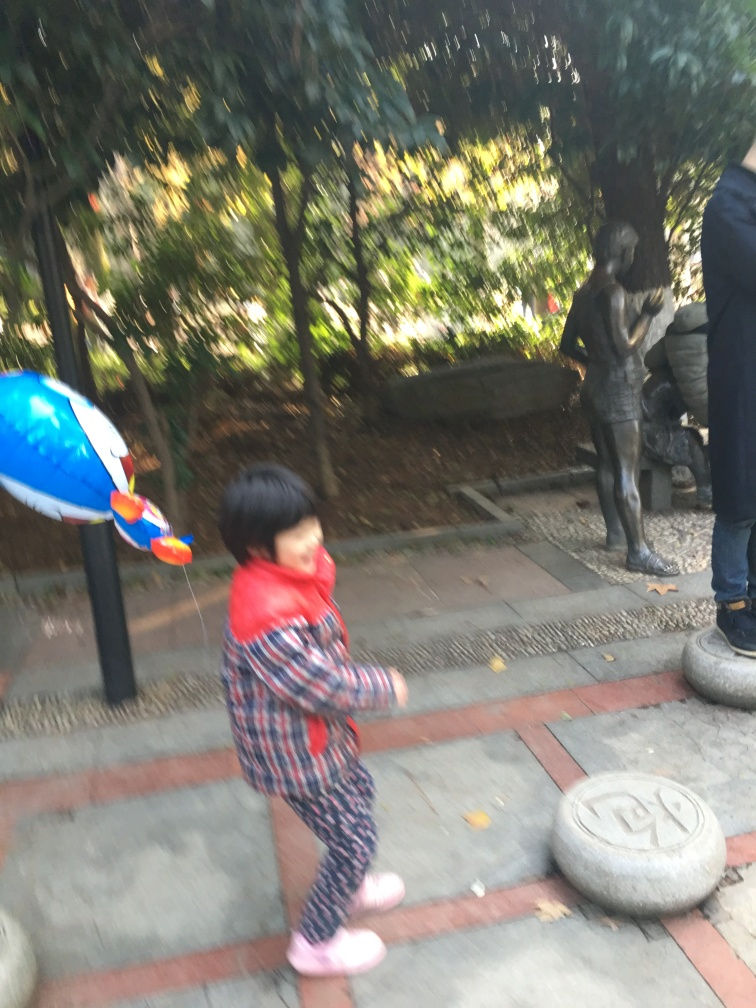Can you describe the setting and the subjects in the photograph? The photograph depicts an outdoor setting with abundant greenery that suggests a park or garden. In the foreground, a young child is in motion, possibly playing, with a blurred profile that conveys movement. The child is holding a colorful object that appears to be a toy. In the mid-ground, there is a statue of a person, and someone else is partially visible beside it. The blurred quality of the image gives it a dynamic feel but makes it difficult to discern precise details. 